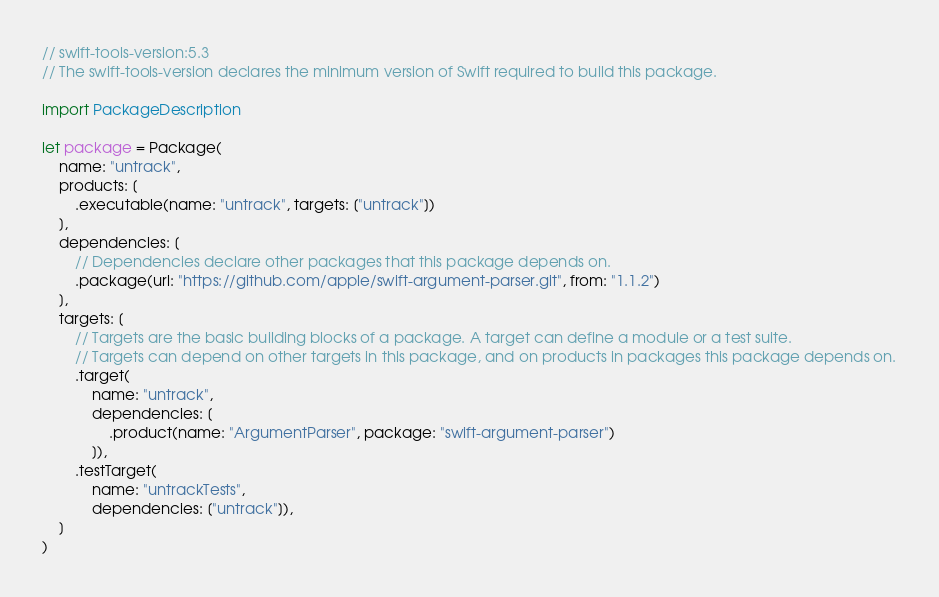Convert code to text. <code><loc_0><loc_0><loc_500><loc_500><_Swift_>// swift-tools-version:5.3
// The swift-tools-version declares the minimum version of Swift required to build this package.

import PackageDescription

let package = Package(
    name: "untrack",
    products: [
        .executable(name: "untrack", targets: ["untrack"])
    ],
    dependencies: [
        // Dependencies declare other packages that this package depends on.
        .package(url: "https://github.com/apple/swift-argument-parser.git", from: "1.1.2")
    ],
    targets: [
        // Targets are the basic building blocks of a package. A target can define a module or a test suite.
        // Targets can depend on other targets in this package, and on products in packages this package depends on.
        .target(
            name: "untrack",
            dependencies: [
                .product(name: "ArgumentParser", package: "swift-argument-parser")
            ]),
        .testTarget(
            name: "untrackTests",
            dependencies: ["untrack"]),
    ]
)
</code> 